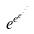Convert formula to latex. <formula><loc_0><loc_0><loc_500><loc_500>e ^ { e ^ { e ^ { \cdot ^ { \cdot ^ { \cdot } } } } }</formula> 